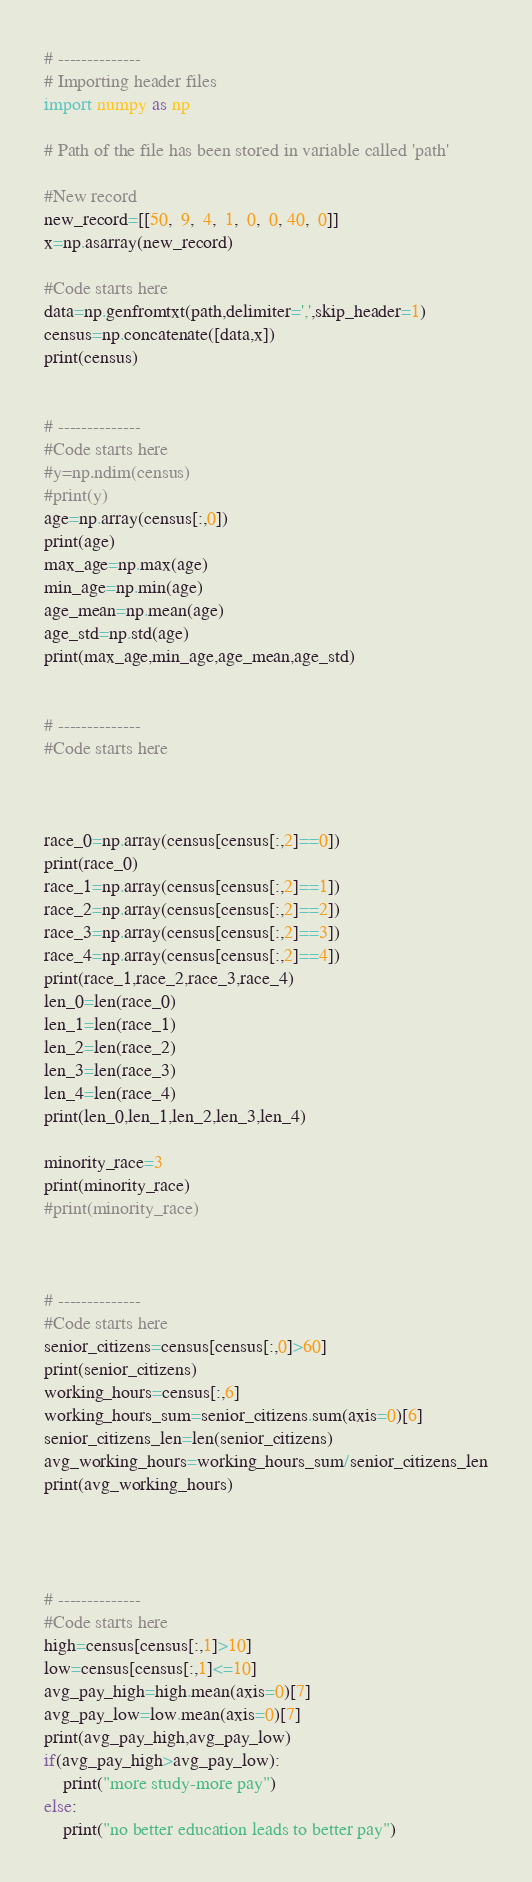<code> <loc_0><loc_0><loc_500><loc_500><_Python_># --------------
# Importing header files
import numpy as np

# Path of the file has been stored in variable called 'path'

#New record
new_record=[[50,  9,  4,  1,  0,  0, 40,  0]]
x=np.asarray(new_record)

#Code starts here
data=np.genfromtxt(path,delimiter=',',skip_header=1)
census=np.concatenate([data,x])
print(census)


# --------------
#Code starts here
#y=np.ndim(census)
#print(y)
age=np.array(census[:,0])
print(age)
max_age=np.max(age)
min_age=np.min(age)
age_mean=np.mean(age)
age_std=np.std(age)
print(max_age,min_age,age_mean,age_std)


# --------------
#Code starts here



race_0=np.array(census[census[:,2]==0])
print(race_0)
race_1=np.array(census[census[:,2]==1])
race_2=np.array(census[census[:,2]==2])
race_3=np.array(census[census[:,2]==3])
race_4=np.array(census[census[:,2]==4])
print(race_1,race_2,race_3,race_4)
len_0=len(race_0)
len_1=len(race_1)
len_2=len(race_2)
len_3=len(race_3)
len_4=len(race_4)
print(len_0,len_1,len_2,len_3,len_4)

minority_race=3
print(minority_race)
#print(minority_race)



# --------------
#Code starts here
senior_citizens=census[census[:,0]>60]
print(senior_citizens)
working_hours=census[:,6]
working_hours_sum=senior_citizens.sum(axis=0)[6]
senior_citizens_len=len(senior_citizens)
avg_working_hours=working_hours_sum/senior_citizens_len
print(avg_working_hours)




# --------------
#Code starts here
high=census[census[:,1]>10]
low=census[census[:,1]<=10]
avg_pay_high=high.mean(axis=0)[7]
avg_pay_low=low.mean(axis=0)[7]
print(avg_pay_high,avg_pay_low)
if(avg_pay_high>avg_pay_low):
    print("more study-more pay")
else:
    print("no better education leads to better pay")



</code> 